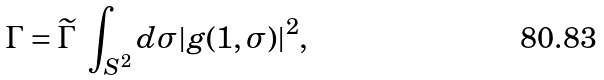<formula> <loc_0><loc_0><loc_500><loc_500>\Gamma = \widetilde { \Gamma } \ \int _ { S ^ { 2 } } d \sigma | g ( 1 , \sigma ) | ^ { 2 } ,</formula> 